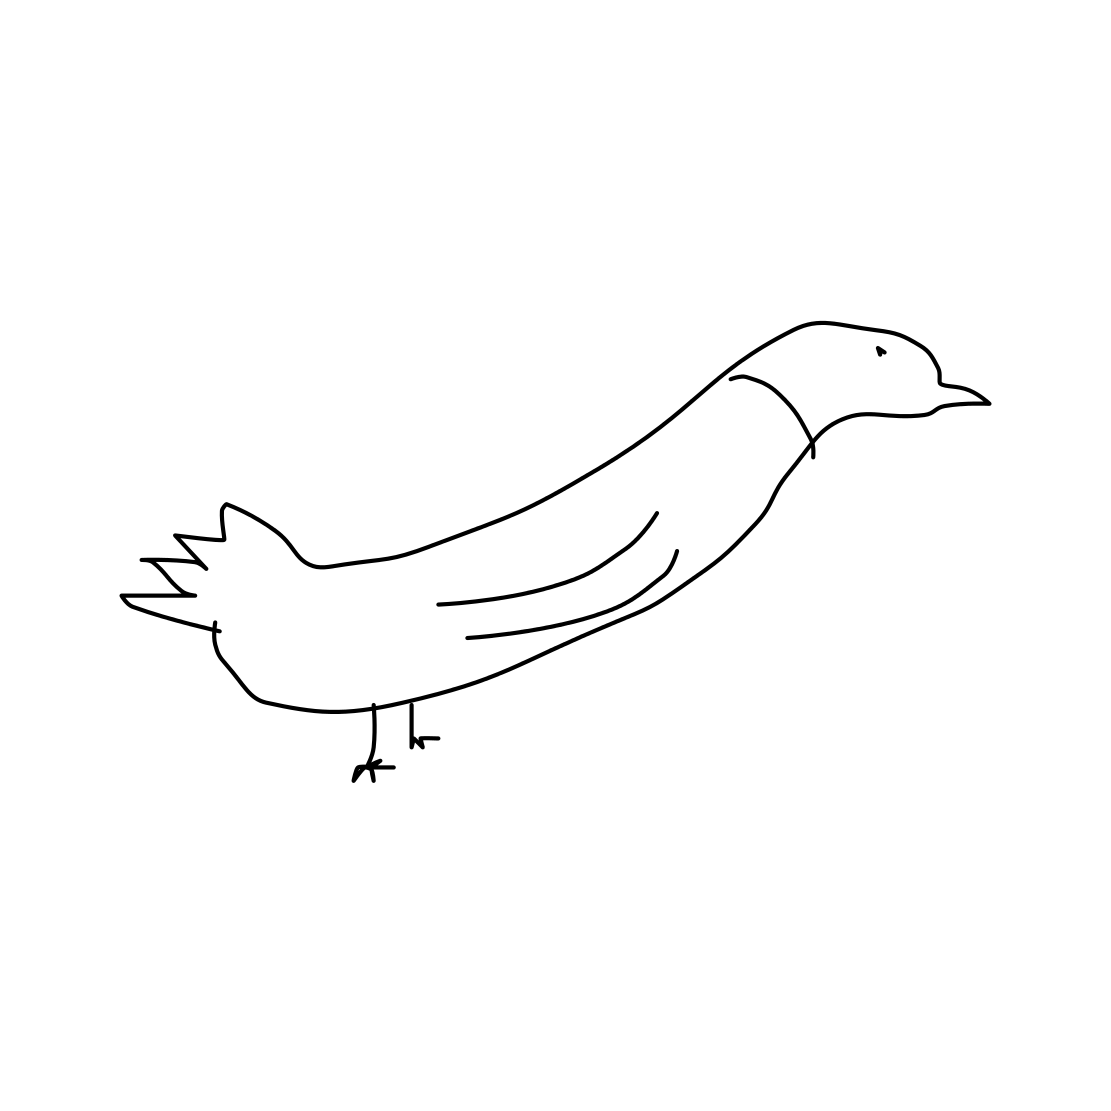What artistic style does this drawing adhere to? The drawing is reminiscent of minimalist art due to its use of clean lines and absence of detail, focusing on the most essential characteristics of the subject. 